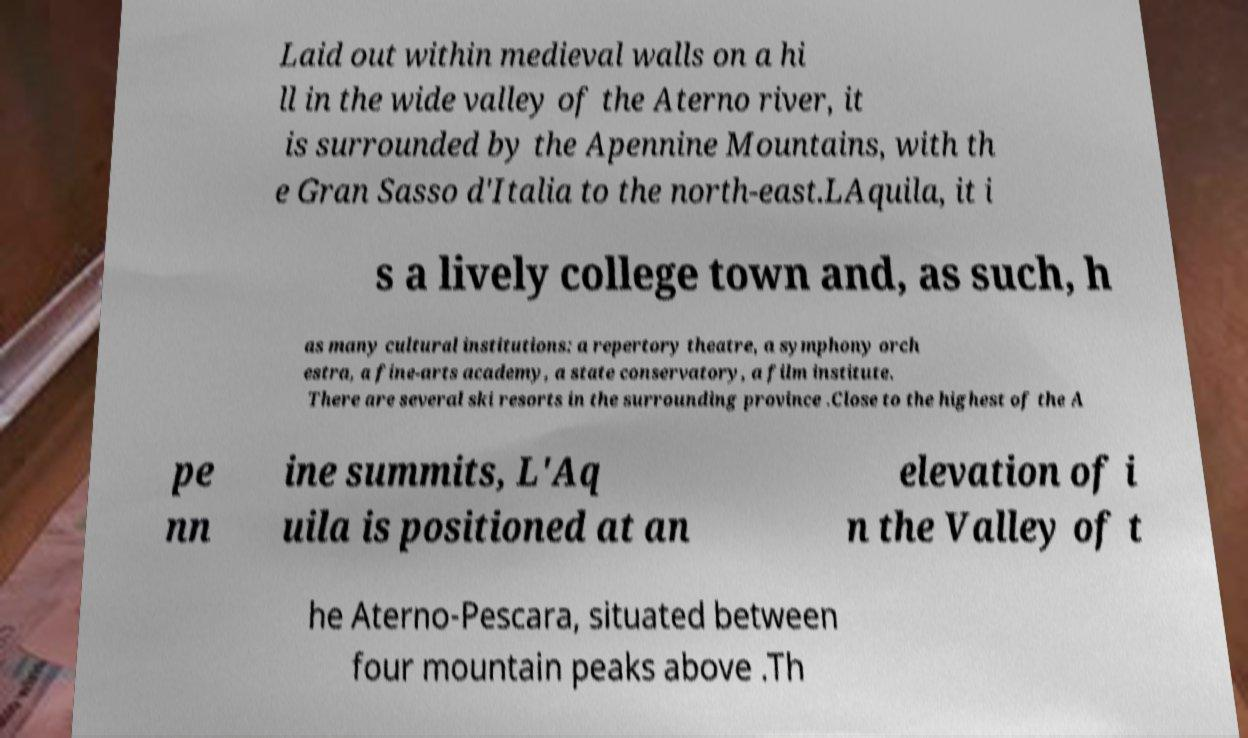Please identify and transcribe the text found in this image. Laid out within medieval walls on a hi ll in the wide valley of the Aterno river, it is surrounded by the Apennine Mountains, with th e Gran Sasso d'Italia to the north-east.LAquila, it i s a lively college town and, as such, h as many cultural institutions: a repertory theatre, a symphony orch estra, a fine-arts academy, a state conservatory, a film institute. There are several ski resorts in the surrounding province .Close to the highest of the A pe nn ine summits, L'Aq uila is positioned at an elevation of i n the Valley of t he Aterno-Pescara, situated between four mountain peaks above .Th 